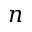Convert formula to latex. <formula><loc_0><loc_0><loc_500><loc_500>n</formula> 